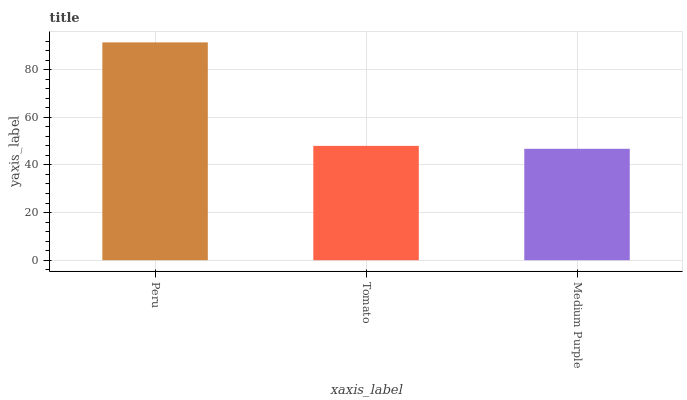Is Medium Purple the minimum?
Answer yes or no. Yes. Is Peru the maximum?
Answer yes or no. Yes. Is Tomato the minimum?
Answer yes or no. No. Is Tomato the maximum?
Answer yes or no. No. Is Peru greater than Tomato?
Answer yes or no. Yes. Is Tomato less than Peru?
Answer yes or no. Yes. Is Tomato greater than Peru?
Answer yes or no. No. Is Peru less than Tomato?
Answer yes or no. No. Is Tomato the high median?
Answer yes or no. Yes. Is Tomato the low median?
Answer yes or no. Yes. Is Medium Purple the high median?
Answer yes or no. No. Is Medium Purple the low median?
Answer yes or no. No. 